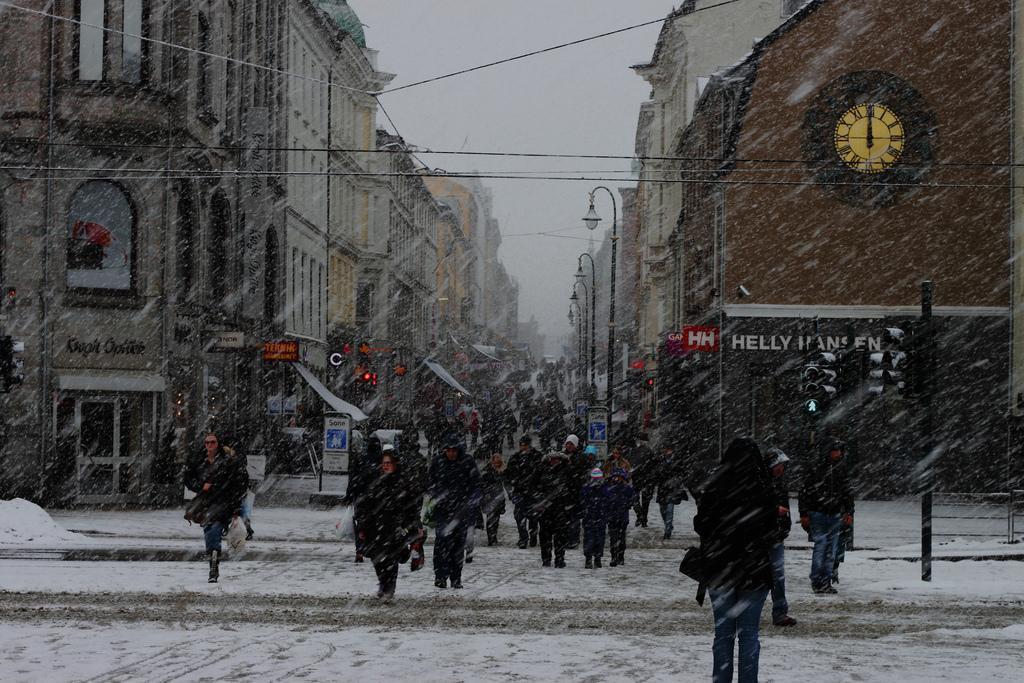How many lamps are visible?
Give a very brief answer. 4. How many clocks?
Give a very brief answer. 1. 